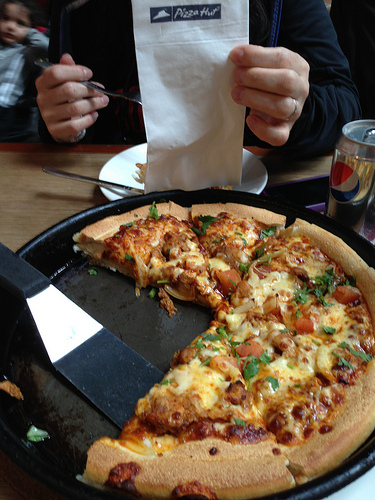Please provide a short description for this region: [0.38, 0.0, 0.62, 0.38]. The region represents the paper that the man is holding. 